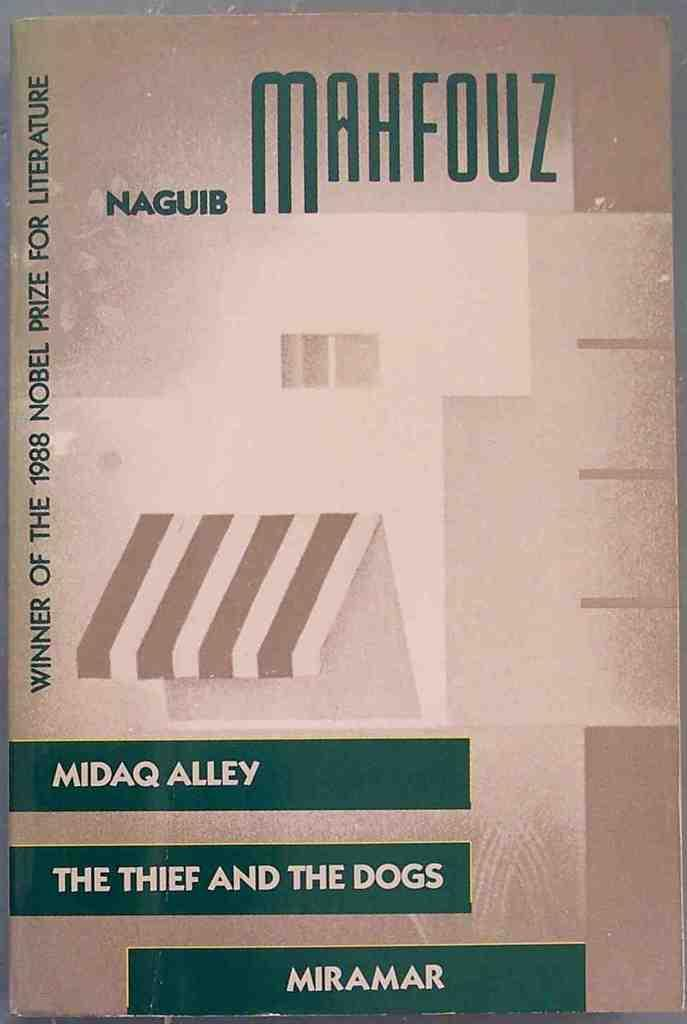What is depicted on the cover page of the book in the image? The image shows the cover page of a book. What colors are used on the book cover? The book cover has brown and cream colors. Is there any text on the book cover? Yes, there is text written on the book cover. What color is the text on the book cover? The text color is green. What is the name of the aunt mentioned in the book cover text? There is no mention of an aunt or any names in the book cover text in the image. 